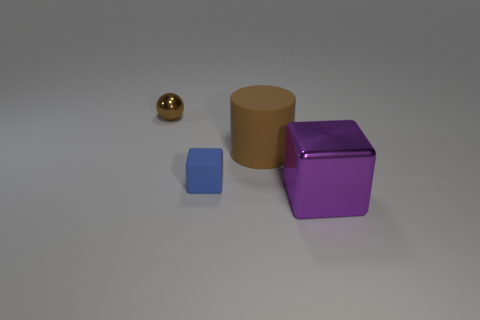What is the lighting like in the scene, and does it create any effects on the surfaces of the objects? The lighting in the scene is soft and diffused, creating gentle highlights and subtle shadows on the objects, enhancing their three-dimensional appearance. 